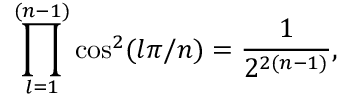<formula> <loc_0><loc_0><loc_500><loc_500>\prod _ { l = 1 } ^ { ( n - 1 ) } \cos ^ { 2 } ( l \pi / n ) = { \frac { 1 } { 2 ^ { 2 ( n - 1 ) } } } ,</formula> 